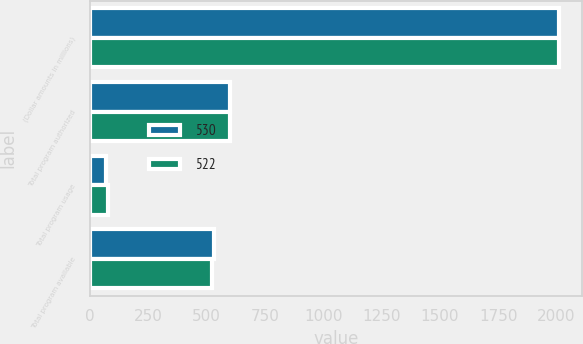<chart> <loc_0><loc_0><loc_500><loc_500><stacked_bar_chart><ecel><fcel>(Dollar amounts in millions)<fcel>Total program authorized<fcel>Total program usage<fcel>Total program available<nl><fcel>530<fcel>2011<fcel>600<fcel>70<fcel>530<nl><fcel>522<fcel>2010<fcel>600<fcel>78<fcel>522<nl></chart> 